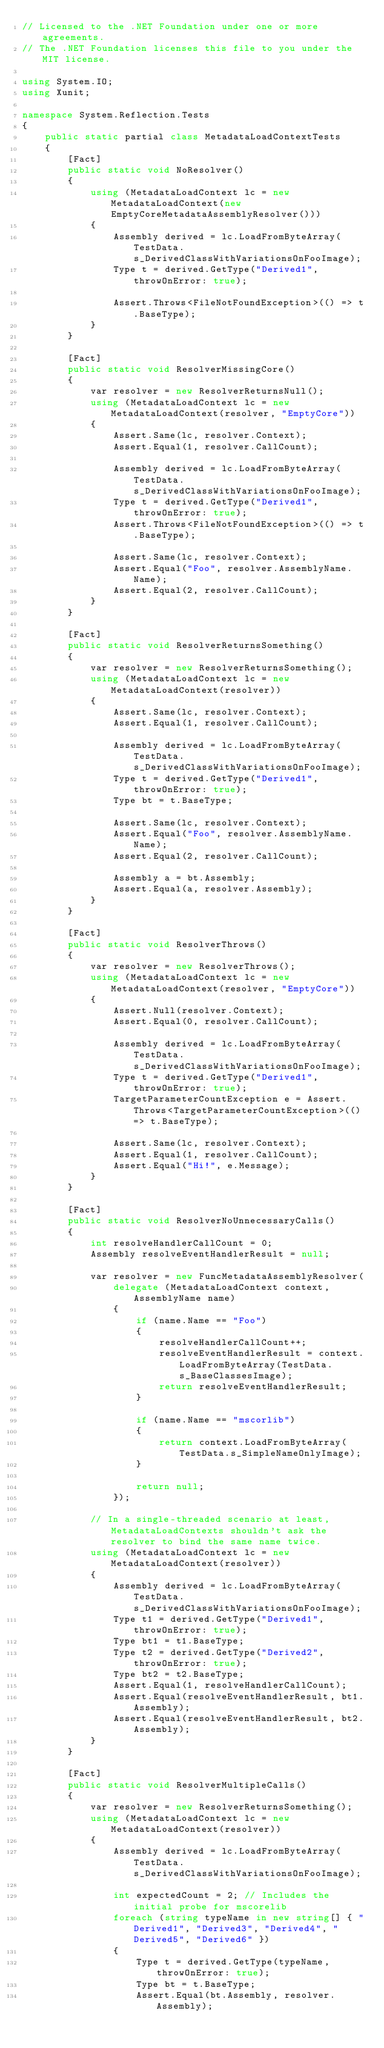<code> <loc_0><loc_0><loc_500><loc_500><_C#_>// Licensed to the .NET Foundation under one or more agreements.
// The .NET Foundation licenses this file to you under the MIT license.

using System.IO;
using Xunit;

namespace System.Reflection.Tests
{
    public static partial class MetadataLoadContextTests
    {
        [Fact]
        public static void NoResolver()
        {
            using (MetadataLoadContext lc = new MetadataLoadContext(new EmptyCoreMetadataAssemblyResolver()))
            {
                Assembly derived = lc.LoadFromByteArray(TestData.s_DerivedClassWithVariationsOnFooImage);
                Type t = derived.GetType("Derived1", throwOnError: true);

                Assert.Throws<FileNotFoundException>(() => t.BaseType);
            }
        }

        [Fact]
        public static void ResolverMissingCore()
        {
            var resolver = new ResolverReturnsNull();
            using (MetadataLoadContext lc = new MetadataLoadContext(resolver, "EmptyCore"))
            {
                Assert.Same(lc, resolver.Context);
                Assert.Equal(1, resolver.CallCount);

                Assembly derived = lc.LoadFromByteArray(TestData.s_DerivedClassWithVariationsOnFooImage);
                Type t = derived.GetType("Derived1", throwOnError: true);
                Assert.Throws<FileNotFoundException>(() => t.BaseType);

                Assert.Same(lc, resolver.Context);
                Assert.Equal("Foo", resolver.AssemblyName.Name);
                Assert.Equal(2, resolver.CallCount);
            }
        }

        [Fact]
        public static void ResolverReturnsSomething()
        {
            var resolver = new ResolverReturnsSomething();
            using (MetadataLoadContext lc = new MetadataLoadContext(resolver))
            {
                Assert.Same(lc, resolver.Context);
                Assert.Equal(1, resolver.CallCount);

                Assembly derived = lc.LoadFromByteArray(TestData.s_DerivedClassWithVariationsOnFooImage);
                Type t = derived.GetType("Derived1", throwOnError: true);
                Type bt = t.BaseType;

                Assert.Same(lc, resolver.Context);
                Assert.Equal("Foo", resolver.AssemblyName.Name);
                Assert.Equal(2, resolver.CallCount);

                Assembly a = bt.Assembly;
                Assert.Equal(a, resolver.Assembly);
            }
        }

        [Fact]
        public static void ResolverThrows()
        {
            var resolver = new ResolverThrows();
            using (MetadataLoadContext lc = new MetadataLoadContext(resolver, "EmptyCore"))
            {
                Assert.Null(resolver.Context);
                Assert.Equal(0, resolver.CallCount);

                Assembly derived = lc.LoadFromByteArray(TestData.s_DerivedClassWithVariationsOnFooImage);
                Type t = derived.GetType("Derived1", throwOnError: true);
                TargetParameterCountException e = Assert.Throws<TargetParameterCountException>(() => t.BaseType);

                Assert.Same(lc, resolver.Context);
                Assert.Equal(1, resolver.CallCount);
                Assert.Equal("Hi!", e.Message);
            }
        }

        [Fact]
        public static void ResolverNoUnnecessaryCalls()
        {
            int resolveHandlerCallCount = 0;
            Assembly resolveEventHandlerResult = null;

            var resolver = new FuncMetadataAssemblyResolver(
                delegate (MetadataLoadContext context, AssemblyName name)
                {
                    if (name.Name == "Foo")
                    {
                        resolveHandlerCallCount++;
                        resolveEventHandlerResult = context.LoadFromByteArray(TestData.s_BaseClassesImage);
                        return resolveEventHandlerResult;
                    }

                    if (name.Name == "mscorlib")
                    {
                        return context.LoadFromByteArray(TestData.s_SimpleNameOnlyImage);
                    }

                    return null;
                });

            // In a single-threaded scenario at least, MetadataLoadContexts shouldn't ask the resolver to bind the same name twice.
            using (MetadataLoadContext lc = new MetadataLoadContext(resolver))
            {
                Assembly derived = lc.LoadFromByteArray(TestData.s_DerivedClassWithVariationsOnFooImage);
                Type t1 = derived.GetType("Derived1", throwOnError: true);
                Type bt1 = t1.BaseType;
                Type t2 = derived.GetType("Derived2", throwOnError: true);
                Type bt2 = t2.BaseType;
                Assert.Equal(1, resolveHandlerCallCount);
                Assert.Equal(resolveEventHandlerResult, bt1.Assembly);
                Assert.Equal(resolveEventHandlerResult, bt2.Assembly);
            }
        }

        [Fact]
        public static void ResolverMultipleCalls()
        {
            var resolver = new ResolverReturnsSomething();
            using (MetadataLoadContext lc = new MetadataLoadContext(resolver))
            {
                Assembly derived = lc.LoadFromByteArray(TestData.s_DerivedClassWithVariationsOnFooImage);

                int expectedCount = 2; // Includes the initial probe for mscorelib
                foreach (string typeName in new string[] { "Derived1", "Derived3", "Derived4", "Derived5", "Derived6" })
                {
                    Type t = derived.GetType(typeName, throwOnError: true);
                    Type bt = t.BaseType;
                    Assert.Equal(bt.Assembly, resolver.Assembly);</code> 